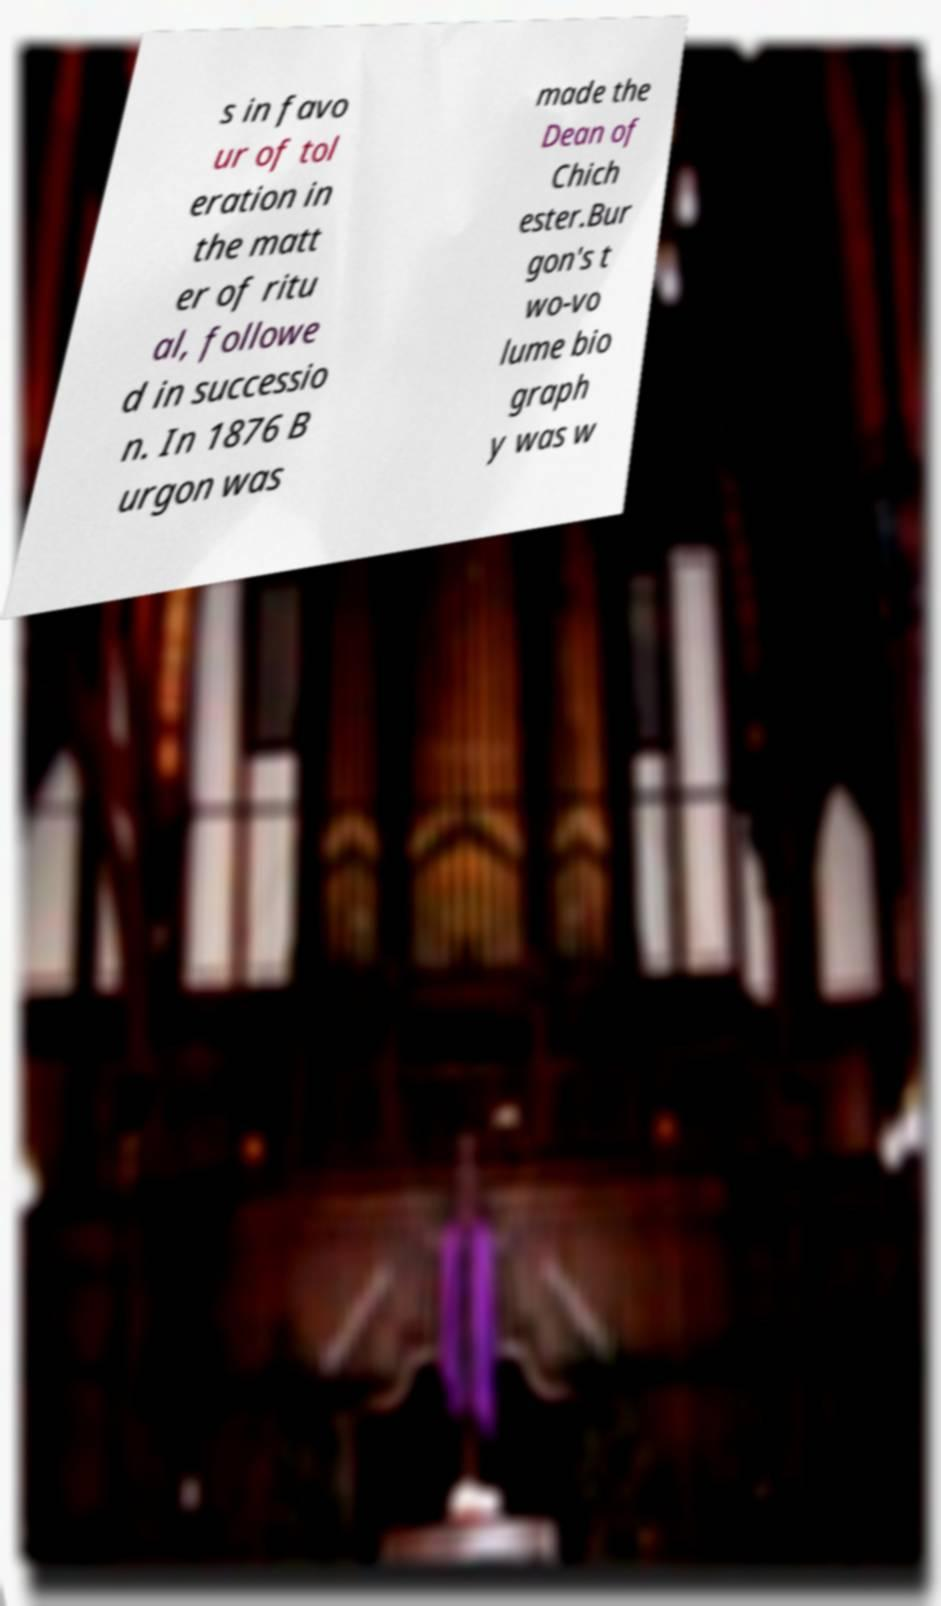For documentation purposes, I need the text within this image transcribed. Could you provide that? s in favo ur of tol eration in the matt er of ritu al, followe d in successio n. In 1876 B urgon was made the Dean of Chich ester.Bur gon's t wo-vo lume bio graph y was w 